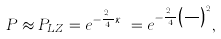<formula> <loc_0><loc_0><loc_500><loc_500>P \approx P _ { L Z } = e ^ { - \frac { \pi ^ { 2 } } { 4 } \kappa _ { R } } = e ^ { - \frac { \pi ^ { 2 } } { 4 } \left ( \frac { B } { B _ { A } } \right ) ^ { 2 } } ,</formula> 